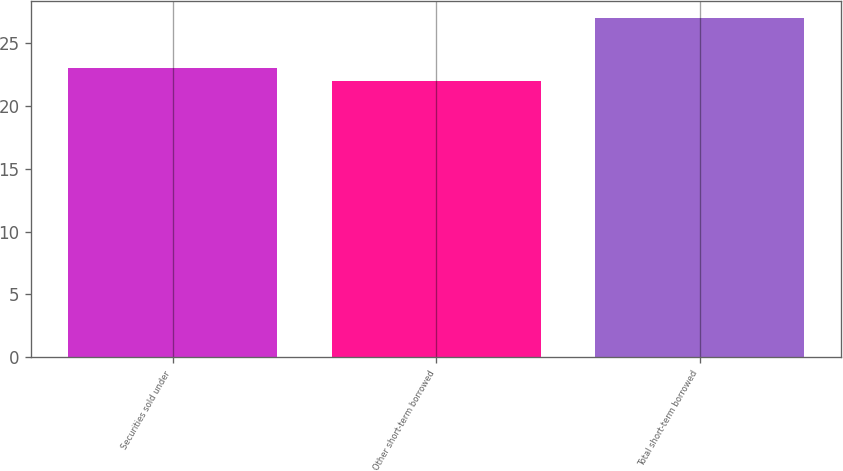Convert chart. <chart><loc_0><loc_0><loc_500><loc_500><bar_chart><fcel>Securities sold under<fcel>Other short-term borrowed<fcel>Total short-term borrowed<nl><fcel>23<fcel>22<fcel>27<nl></chart> 